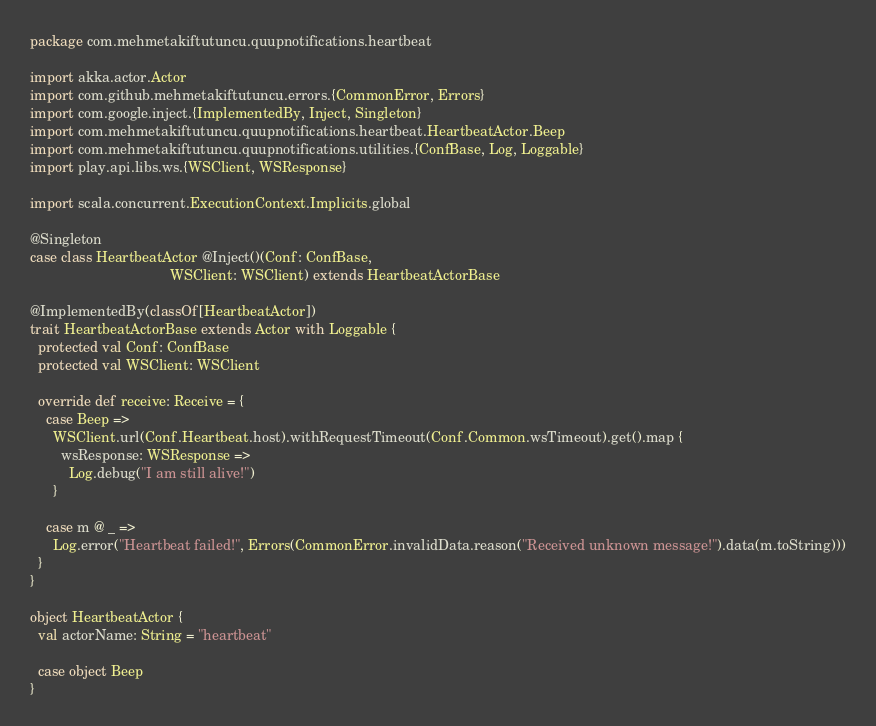Convert code to text. <code><loc_0><loc_0><loc_500><loc_500><_Scala_>package com.mehmetakiftutuncu.quupnotifications.heartbeat

import akka.actor.Actor
import com.github.mehmetakiftutuncu.errors.{CommonError, Errors}
import com.google.inject.{ImplementedBy, Inject, Singleton}
import com.mehmetakiftutuncu.quupnotifications.heartbeat.HeartbeatActor.Beep
import com.mehmetakiftutuncu.quupnotifications.utilities.{ConfBase, Log, Loggable}
import play.api.libs.ws.{WSClient, WSResponse}

import scala.concurrent.ExecutionContext.Implicits.global

@Singleton
case class HeartbeatActor @Inject()(Conf: ConfBase,
                                    WSClient: WSClient) extends HeartbeatActorBase

@ImplementedBy(classOf[HeartbeatActor])
trait HeartbeatActorBase extends Actor with Loggable {
  protected val Conf: ConfBase
  protected val WSClient: WSClient

  override def receive: Receive = {
    case Beep =>
      WSClient.url(Conf.Heartbeat.host).withRequestTimeout(Conf.Common.wsTimeout).get().map {
        wsResponse: WSResponse =>
          Log.debug("I am still alive!")
      }

    case m @ _ =>
      Log.error("Heartbeat failed!", Errors(CommonError.invalidData.reason("Received unknown message!").data(m.toString)))
  }
}

object HeartbeatActor {
  val actorName: String = "heartbeat"

  case object Beep
}
</code> 